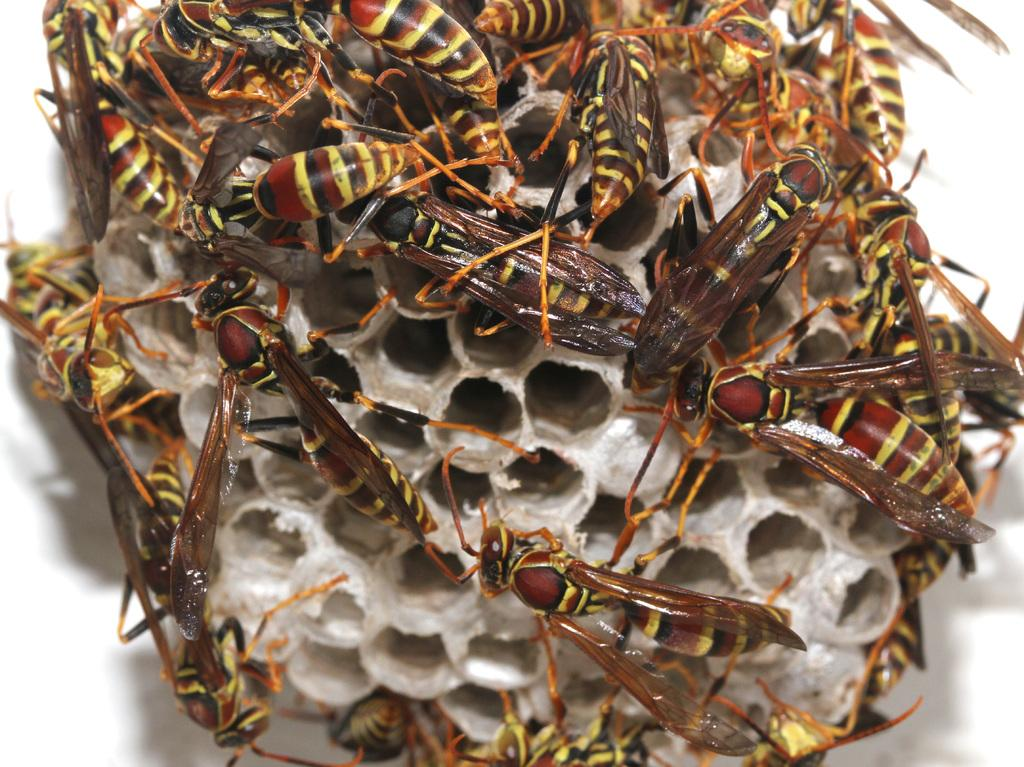What is the main subject in the center of the image? There is a honeycomb in the center of the image. What can be seen on the honeycomb? There are many honey bees on the honeycomb. How does the honeycomb help the cream in the image? There is no cream present in the image, and the honeycomb does not help any cream. 